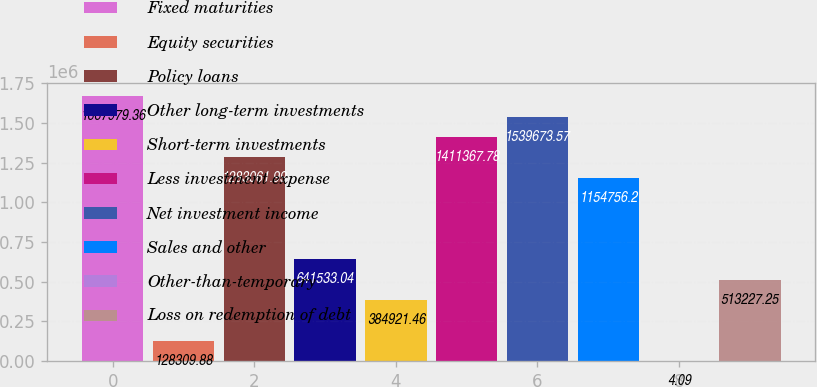Convert chart to OTSL. <chart><loc_0><loc_0><loc_500><loc_500><bar_chart><fcel>Fixed maturities<fcel>Equity securities<fcel>Policy loans<fcel>Other long-term investments<fcel>Short-term investments<fcel>Less investment expense<fcel>Net investment income<fcel>Sales and other<fcel>Other-than-temporary<fcel>Loss on redemption of debt<nl><fcel>1.66798e+06<fcel>128310<fcel>1.28306e+06<fcel>641533<fcel>384921<fcel>1.41137e+06<fcel>1.53967e+06<fcel>1.15476e+06<fcel>4.09<fcel>513227<nl></chart> 